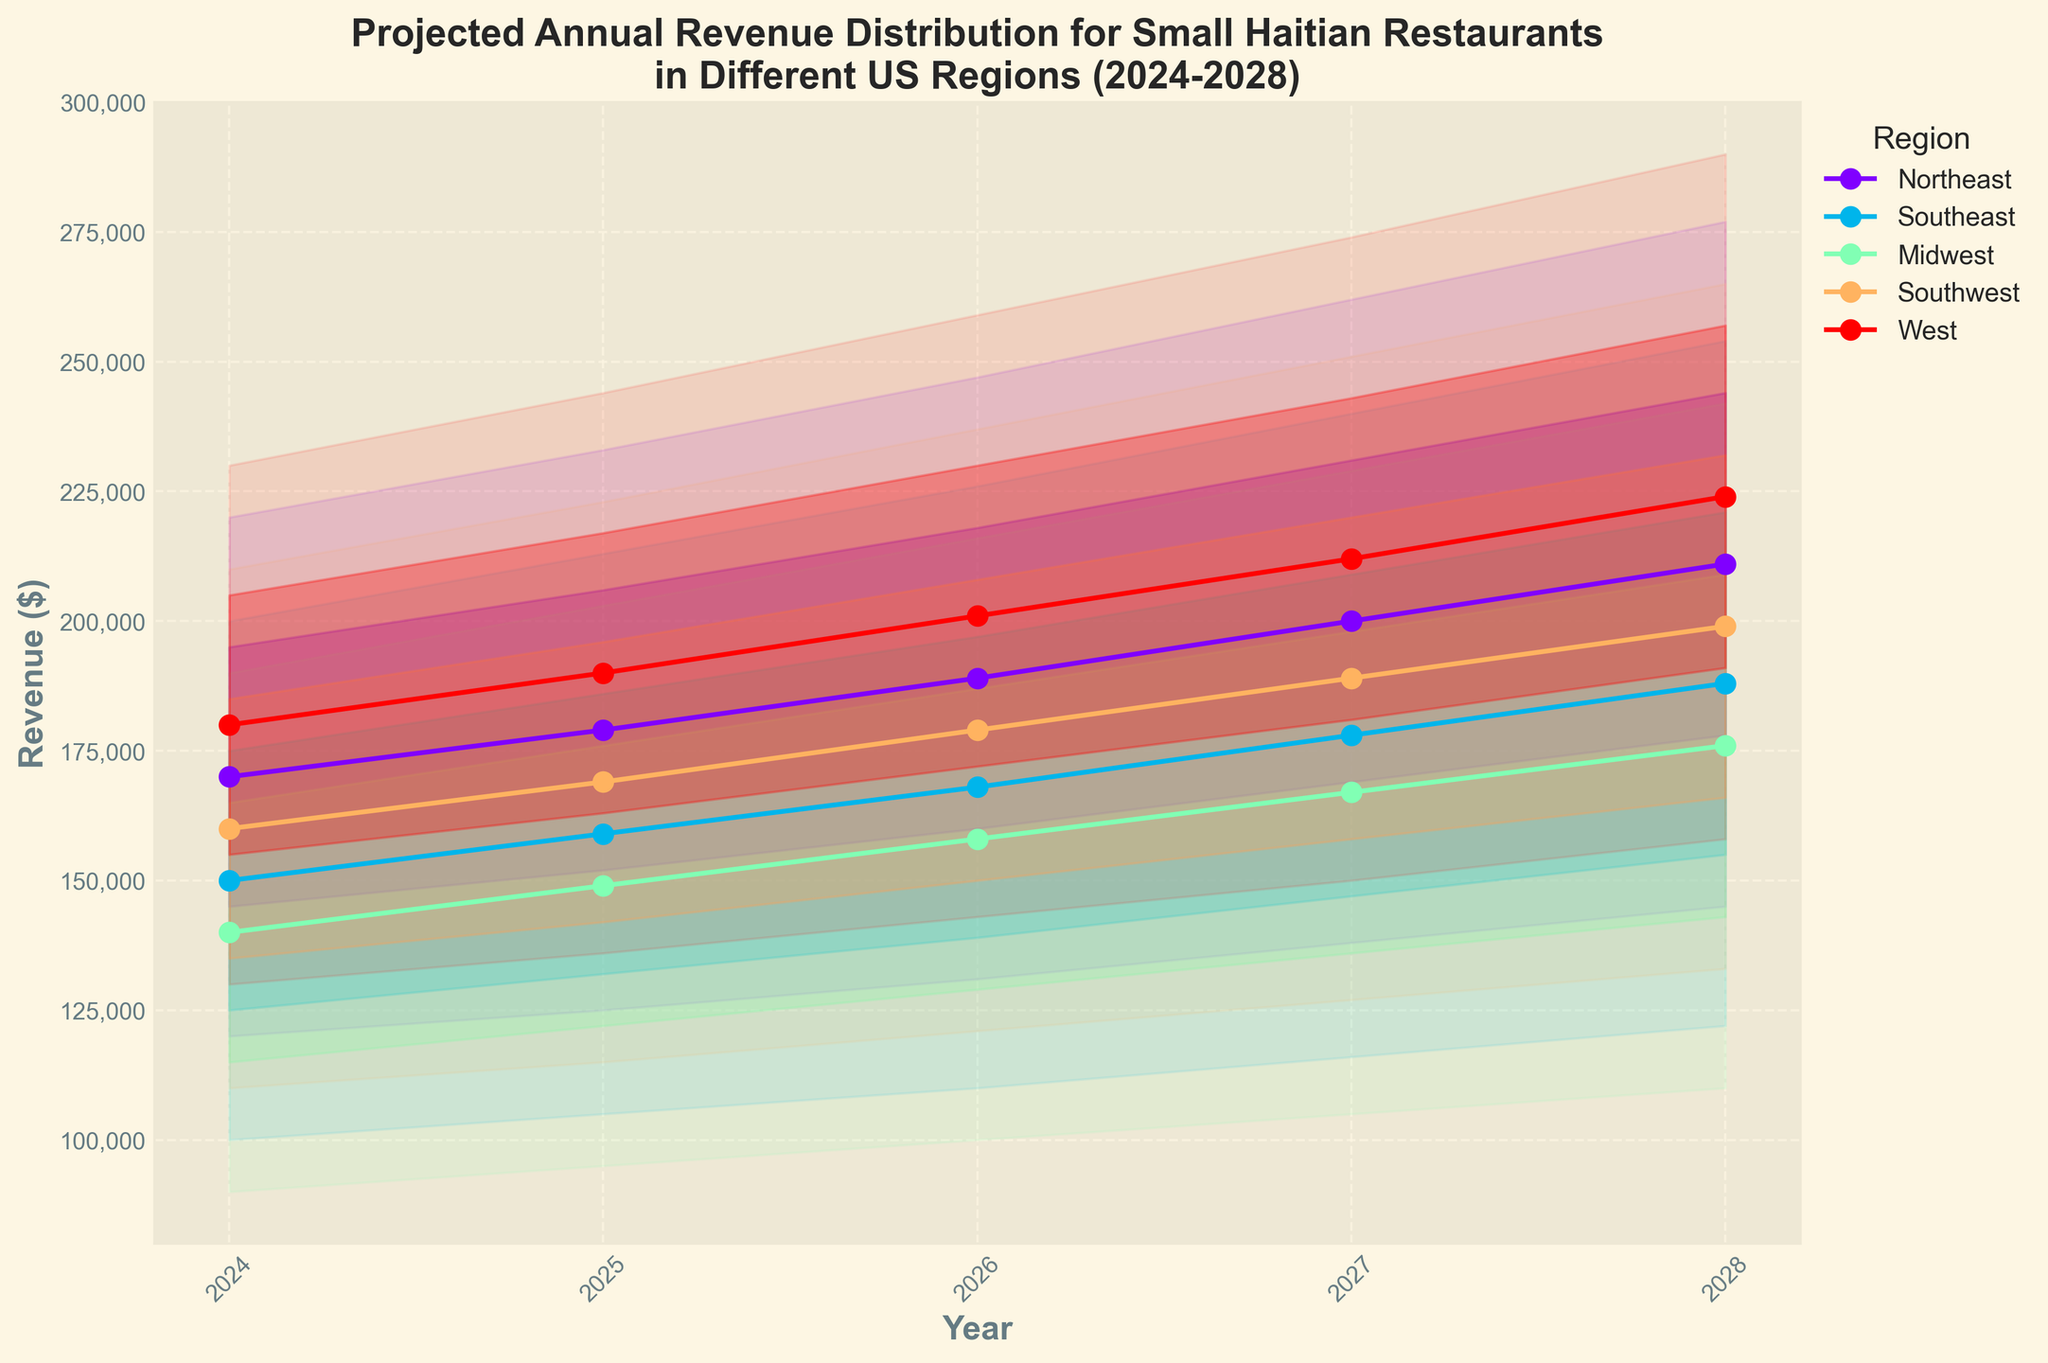What is the title of the chart? The title of the chart is prominently located at the top and is typically the first text visible. It provides context about what the chart represents.
Answer: Projected Annual Revenue Distribution for Small Haitian Restaurants in Different US Regions (2024-2028) Which region has the highest median projected revenue in 2028? To find the answer, locate the lines labeled for each region, then find the 2028 data point on the X-axis and the corresponding median data point (middle line) on the Y-axis. Compare all regions.
Answer: West What is the projected median revenue for the Southeast region in 2026? Locate the line representing the Southeast region, find the year 2026 on the X-axis, and then find the median value on this line for the corresponding year on the Y-axis.
Answer: 168,000 Which region shows the narrowest revenue range (Upper Bound - Lower Bound) in 2024? To determine the narrowest range, calculate the difference between the Upper Bound and Lower Bound for each region in 2024, and then compare these differences.
Answer: Midwest How does the projected median revenue for the Midwest region change from 2024 to 2028? Find the median values for the Midwest region for the years 2024 and 2028 on the Y-axis, then calculate the difference between these two values.
Answer: Increases by 36,000 (from 140,000 to 176,000) Which region has the steepest increase in revenue according to the upper middle range between 2024 and 2028? Examine the upper middle values for each region for the years 2024 and 2028, calculate the difference, and determine which has the largest increase.
Answer: West Compare the range of projected revenues (from Lower Bound to Upper Bound) for the Northeast and West regions in 2027. Which region has a broader range? Calculate the range (Upper Bound - Lower Bound) for both Northeast and West in 2027, then compare these values.
Answer: West (124,000 compared to 124,000 for Northeast) What is the upper middle value for the Southwest region in 2025? Locate the Southwest region, find the year 2025, and then find the upper middle data point on the Y-axis.
Answer: 196,000 Which region's median revenue is projected to cross the 200,000 mark first, and in what year does it happen? Look at the median lines for each region and check the earliest year where the median value crosses 200,000.
Answer: Northeast, in 2027 What is the difference between the lower middle and upper middle projected revenues for the Southeast region in 2028? For the Southeast region in 2028, find the lower middle and the upper middle values on the Y-axis, then subtract the lower middle value from the upper middle value.
Answer: 66,000 (221,000 - 155,000) 